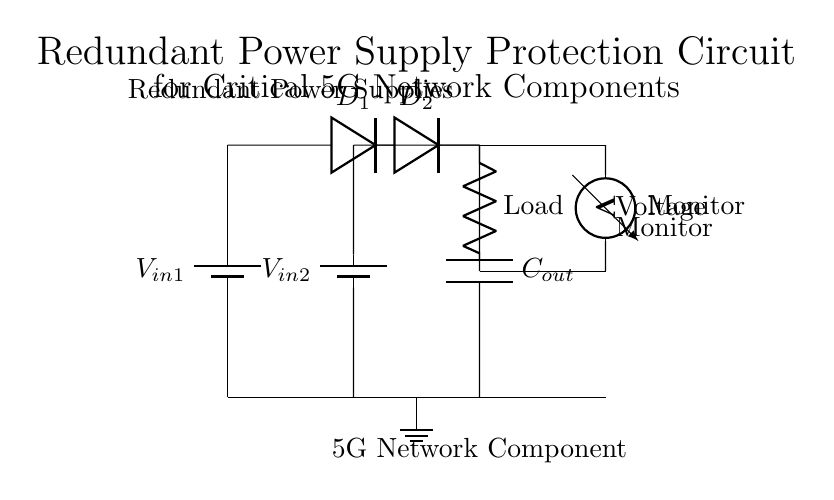What power sources are used in this circuit? The circuit uses two battery sources labeled V in 1 and V in 2 as its primary power inputs.
Answer: V in 1, V in 2 What type of diodes are used in this circuit? The circuit diagram shows two diodes, specifically labeled D1 and D2, which are used to ensure current flows from the power sources to the load while preventing backflow.
Answer: Diodes What component monitors the voltage in the circuit? A voltmeter is included in the circuit to monitor the voltage between the output and ground, ensuring the load receives the correct voltage supply.
Answer: Voltmeter Why are two power supplies used in this circuit? The use of two power supplies provides redundancy, allowing one to take over if the other fails, which is essential for maintaining the operation of critical network components without interruption.
Answer: Redundancy What is the role of the output capacitor in this circuit? The output capacitor smooths the voltage supplied to the load, helping to filter any fluctuations and maintain a stable voltage output for the critical 5G network component.
Answer: Smoothing voltage What connects the output of the diodes to the load? The circuit shows a direct connection from the output of the diodes to the load, which ensures that the load receives power from both redundant sources through the diodes.
Answer: Direct connection What is the purpose of having a load labeled in the circuit? The load represents the critical 5G network component that requires a stable power supply, ensuring that this component can operate without disruption.
Answer: Power supply for 5G component 